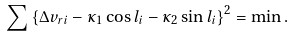<formula> <loc_0><loc_0><loc_500><loc_500>\sum \left \{ \Delta v _ { r i } - \kappa _ { 1 } \cos l _ { i } - \kappa _ { 2 } \sin l _ { i } \right \} ^ { 2 } = \min .</formula> 